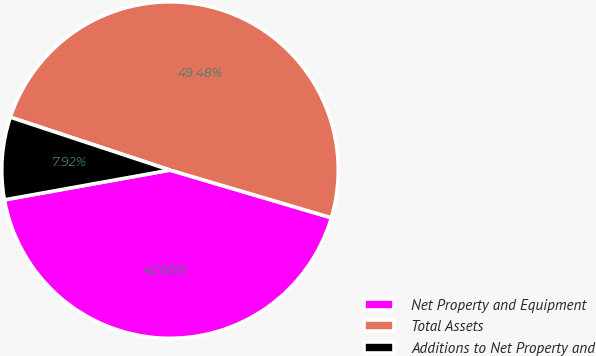Convert chart to OTSL. <chart><loc_0><loc_0><loc_500><loc_500><pie_chart><fcel>Net Property and Equipment<fcel>Total Assets<fcel>Additions to Net Property and<nl><fcel>42.6%<fcel>49.48%<fcel>7.92%<nl></chart> 